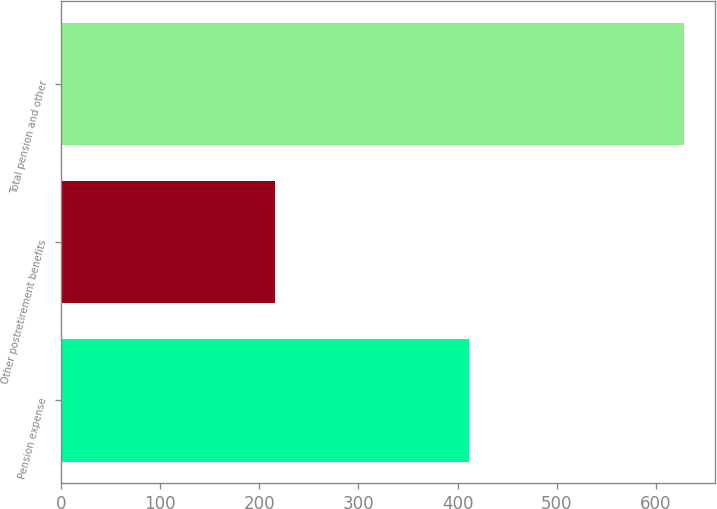Convert chart. <chart><loc_0><loc_0><loc_500><loc_500><bar_chart><fcel>Pension expense<fcel>Other postretirement benefits<fcel>Total pension and other<nl><fcel>412<fcel>216<fcel>628<nl></chart> 